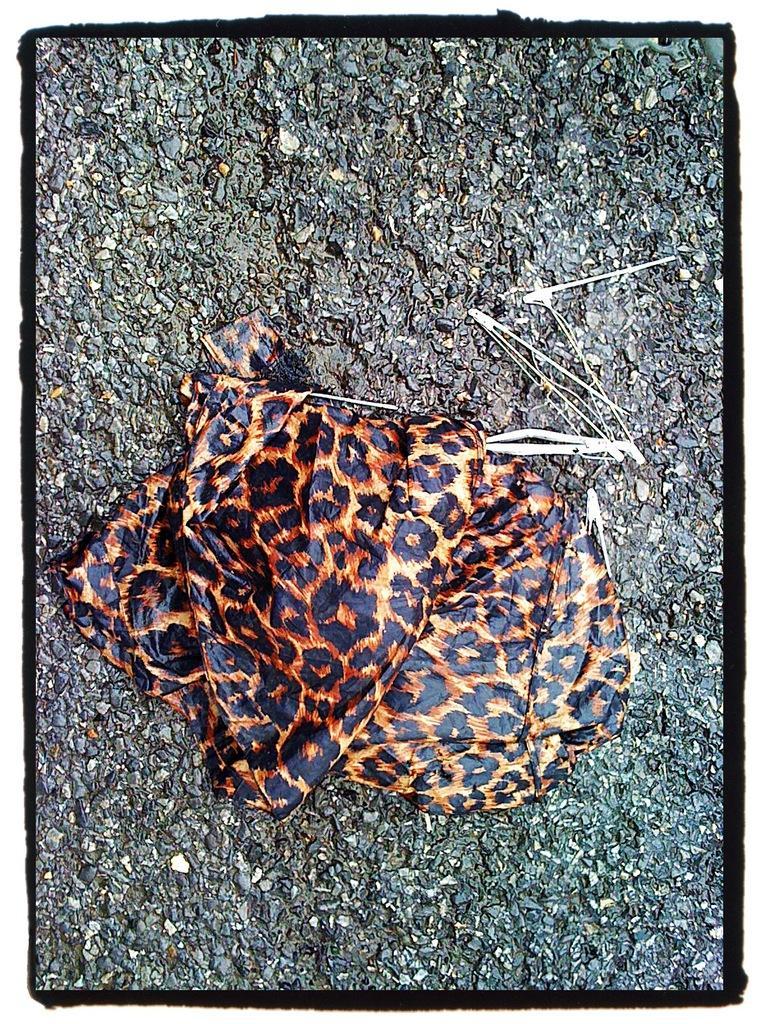Could you give a brief overview of what you see in this image? In the picture we can see a surface on it we can see a leopard skin design cloth on it. 